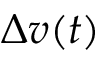<formula> <loc_0><loc_0><loc_500><loc_500>\Delta v ( t )</formula> 